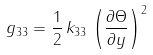Convert formula to latex. <formula><loc_0><loc_0><loc_500><loc_500>g _ { 3 3 } = \frac { 1 } { 2 } \, k _ { 3 3 } \, \left ( \frac { \partial \Theta } { \partial y } \right ) ^ { 2 }</formula> 